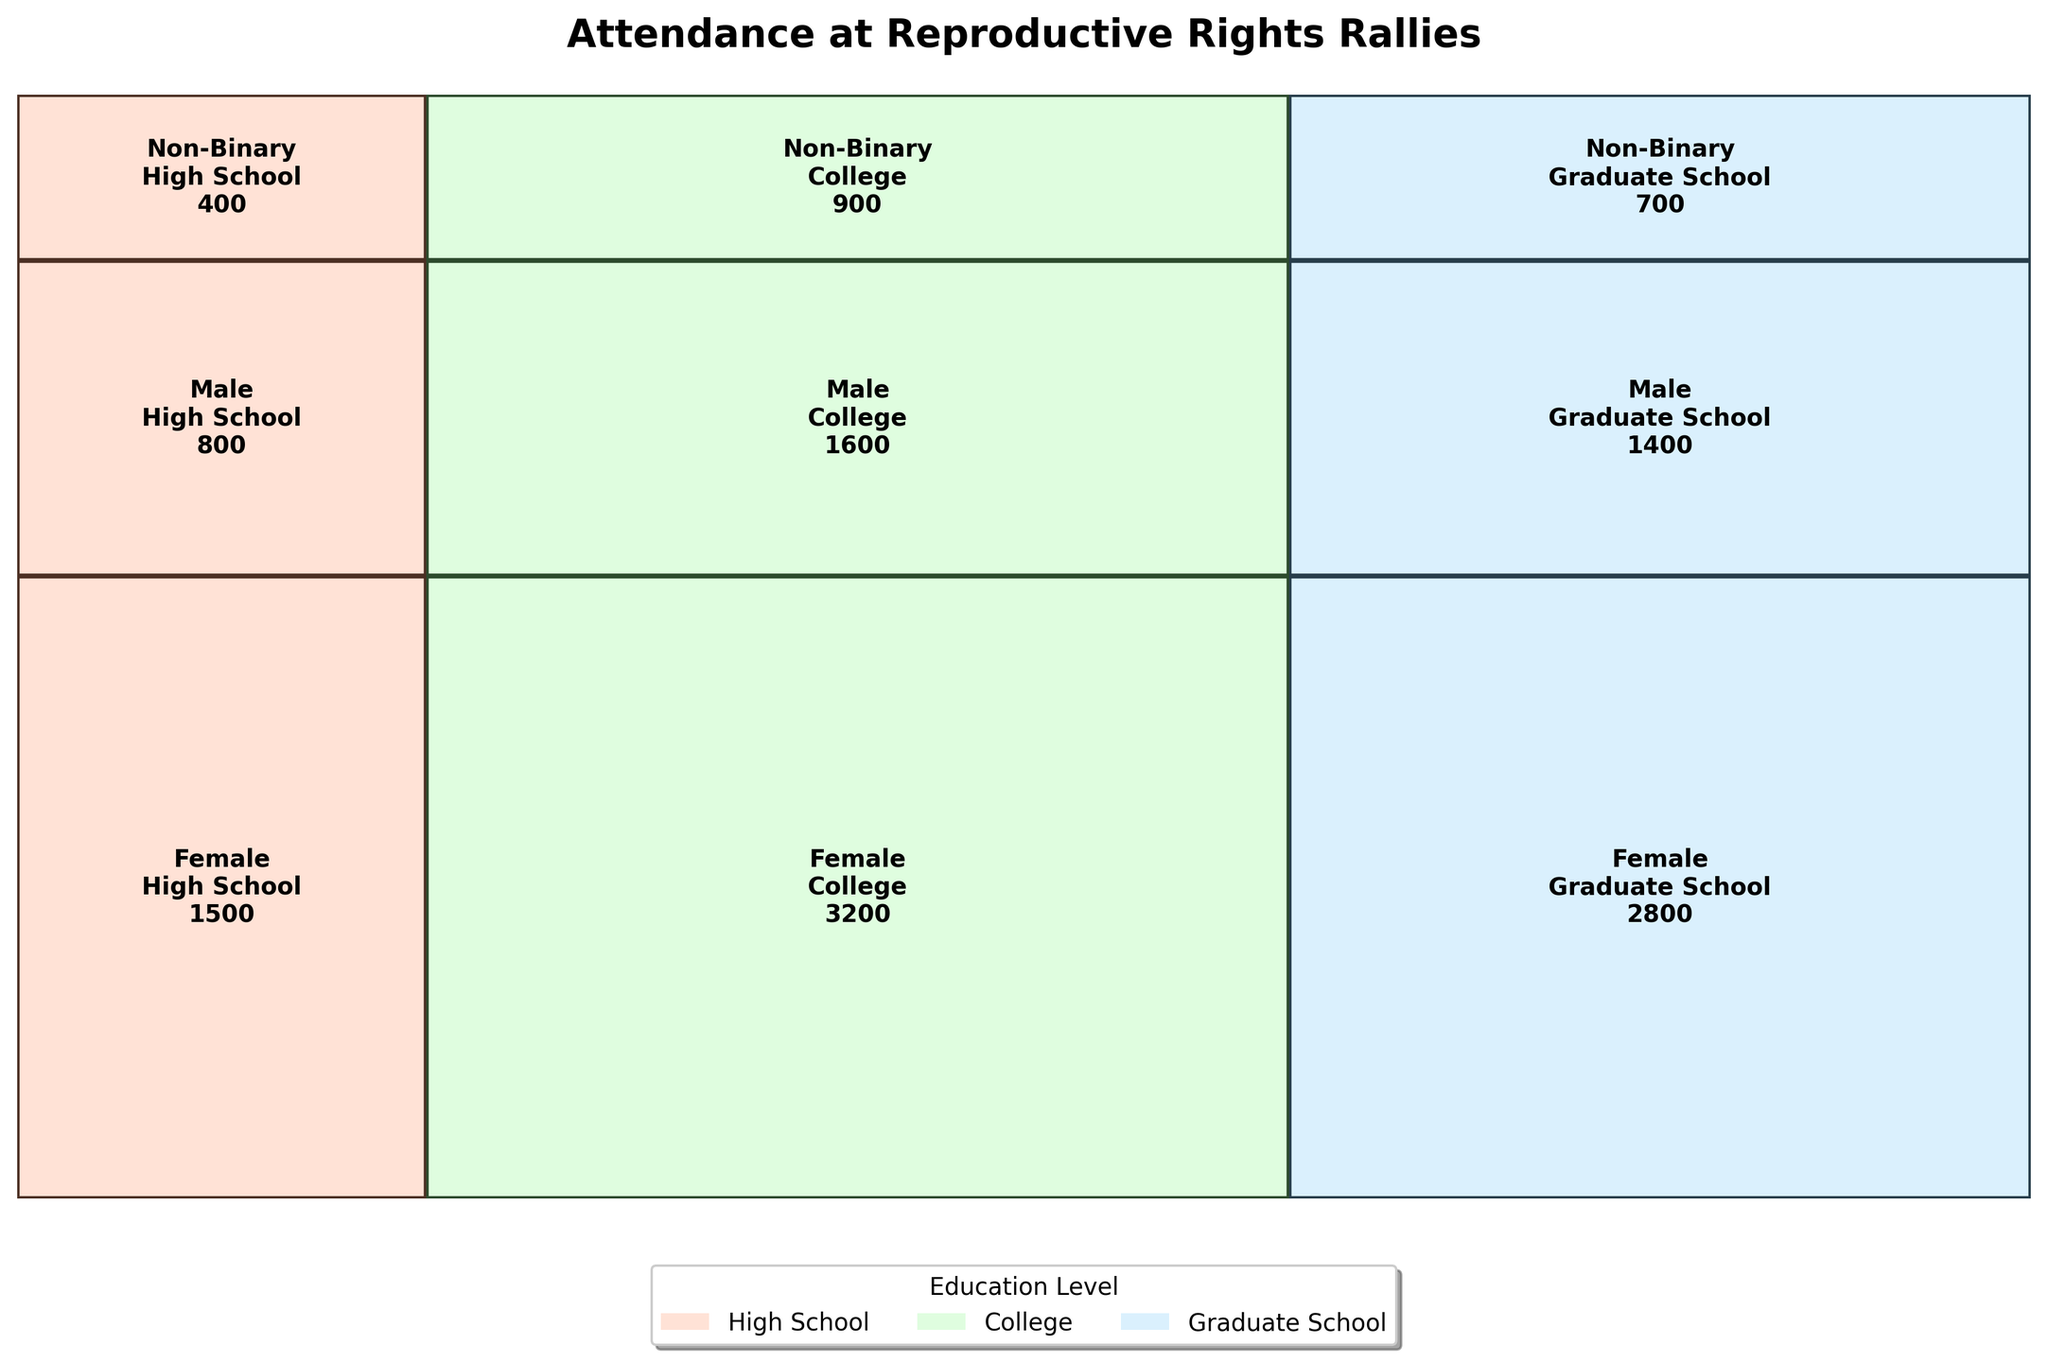What's the title of the plot? The title can be found at the top of the figure. It summarizes what the plot is about.
Answer: Attendance at Reproductive Rights Rallies How many gender categories are displayed in the plot? By observing the plot, we can see the labels indicating different gender identities. Count these labels.
Answer: 3 Which education level had the highest attendance for non-binary individuals? Locate the non-binary section and compare the values across different education levels. The highest value indicates the education level with the highest attendance.
Answer: College What is the total attendance for female attendees? Identify the attendance numbers for females across all education levels and sum them up.
Answer: 1500 + 3200 + 2800 = 7500 How does the attendance for males with a college education compare to those with high school education? Find the attendance values for males with college and high school education and then compare them.
Answer: 1600 (College) is greater than 800 (High School) Which education level had the least attendance overall? Sum the attendance numbers for each education level across all gender identities and determine the lowest value.
Answer: High School (1500 + 800 + 400 = 2700) What's the attendance difference between college-educated females and college-educated males? Subtract the college-educated male attendance from the college-educated female attendance.
Answer: 3200 - 1600 = 1600 Which gender had the least total attendance? Sum the attendance figures for each gender and identify the one with the lowest total.
Answer: Non-Binary (400 + 900 + 700 = 2000) How does the attendance of graduate school-educated males compare to non-binary individuals with the same education level? Compare the attendance numbers under "Graduate School" for males and non-binary individuals.
Answer: 1400 (Male) is greater than 700 (Non-Binary) Between females and males, which gender showed a higher total attendance in rallies? Sum the attendance figures for females and males, then compare the totals.
Answer: Female (7500) is higher than Male (3800) 